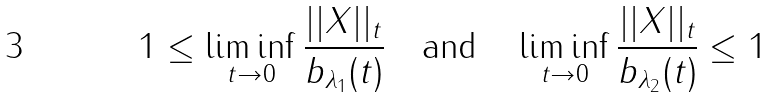<formula> <loc_0><loc_0><loc_500><loc_500>1 \leq \liminf _ { t \rightarrow 0 } \frac { | | X | | _ { t } } { b _ { \lambda _ { 1 } } ( t ) } \quad \text {and} \quad \liminf _ { t \rightarrow 0 } \frac { | | X | | _ { t } } { b _ { \lambda _ { 2 } } ( t ) } \leq 1</formula> 